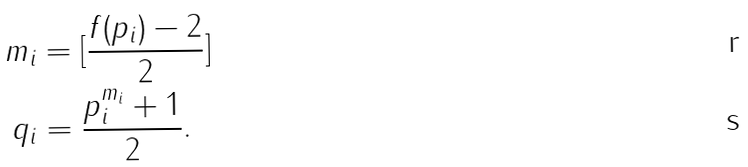Convert formula to latex. <formula><loc_0><loc_0><loc_500><loc_500>m _ { i } & = [ \frac { f ( p _ { i } ) - 2 } { 2 } ] \\ q _ { i } & = \frac { p _ { i } ^ { m _ { i } } + 1 } { 2 } .</formula> 